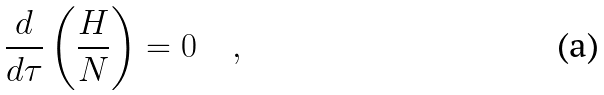<formula> <loc_0><loc_0><loc_500><loc_500>\frac { d } { d \tau } \left ( \frac { H } { N } \right ) = 0 \quad ,</formula> 